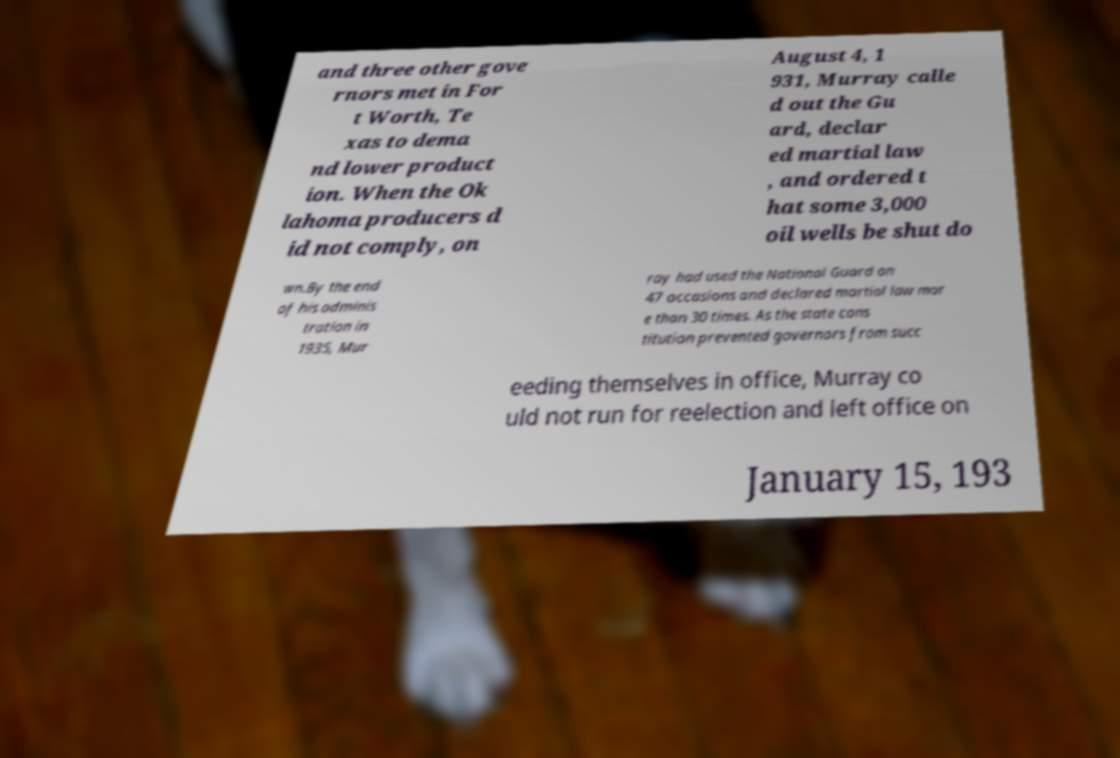Can you read and provide the text displayed in the image?This photo seems to have some interesting text. Can you extract and type it out for me? and three other gove rnors met in For t Worth, Te xas to dema nd lower product ion. When the Ok lahoma producers d id not comply, on August 4, 1 931, Murray calle d out the Gu ard, declar ed martial law , and ordered t hat some 3,000 oil wells be shut do wn.By the end of his adminis tration in 1935, Mur ray had used the National Guard on 47 occasions and declared martial law mor e than 30 times. As the state cons titution prevented governors from succ eeding themselves in office, Murray co uld not run for reelection and left office on January 15, 193 